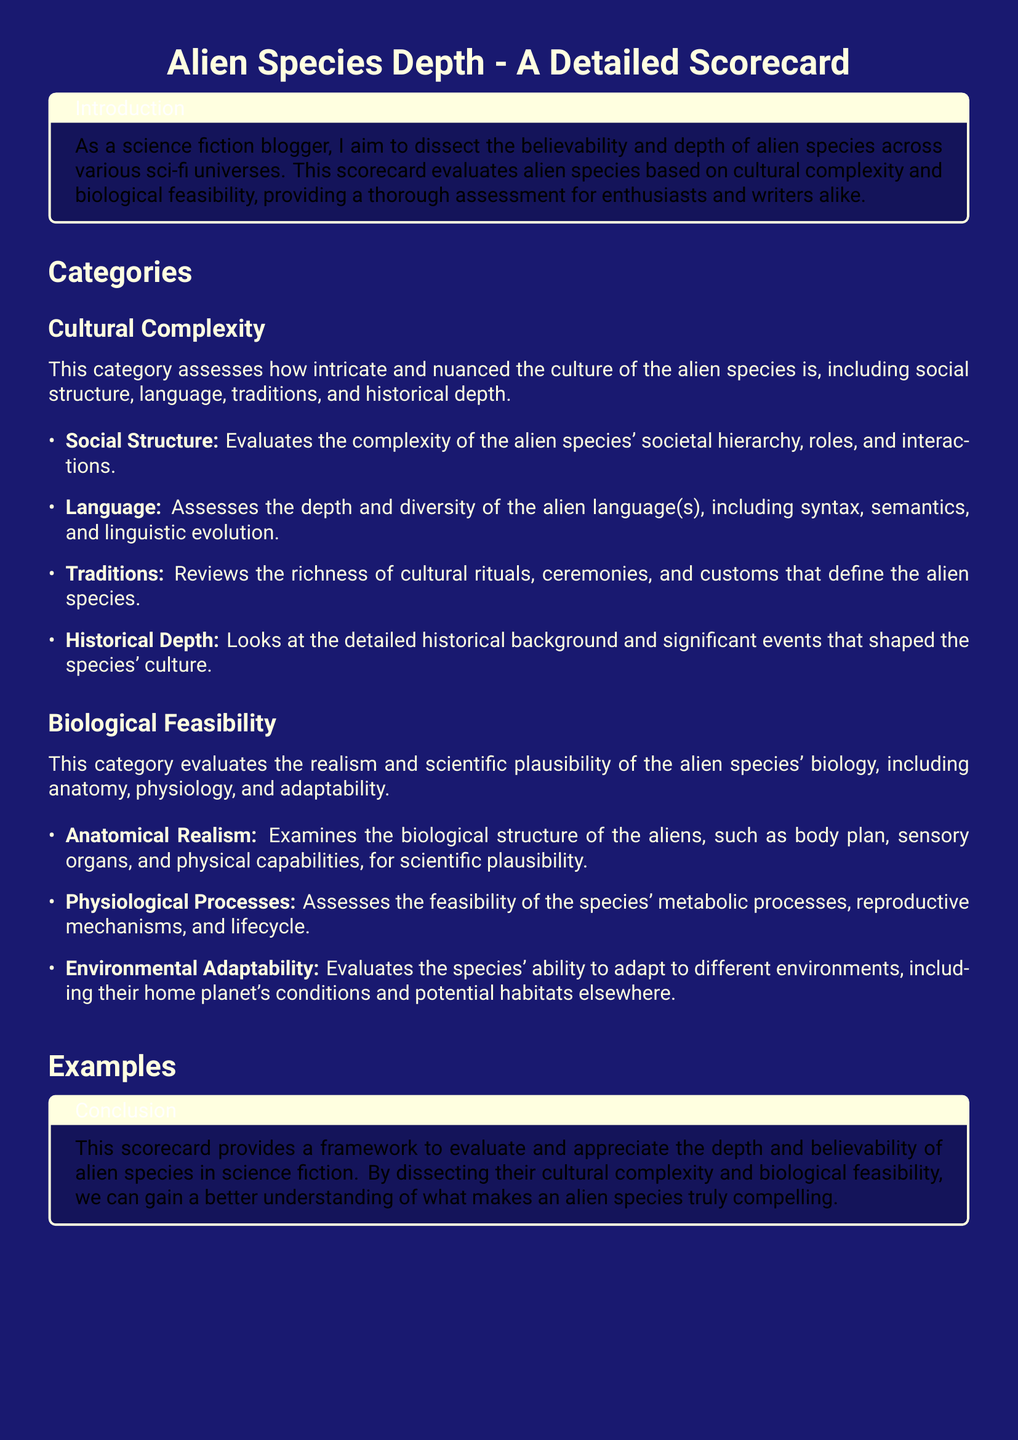What is the title of the scorecard? The title of the scorecard is prominently displayed at the beginning of the document, which is "Alien Species Depth - A Detailed Scorecard."
Answer: Alien Species Depth - A Detailed Scorecard What is the cultural complexity score for Vulcans? The cultural complexity score for Vulcans is mentioned in the examples section of the scorecard.
Answer: 9 What species is described as having a cultural complexity score of 5? The species with a cultural complexity score of 5 is listed in the examples provided, which refers to the Protogen Molecule-Infected.
Answer: Protogen Molecule-Infected How many categories are used to evaluate the alien species? The scorecard outlines two main categories for evaluation, which are cultural complexity and biological feasibility.
Answer: 2 What is the lowest biological feasibility score mentioned? The biological feasibility scores for the examples are listed, and the lowest score is identified in the table for the Wookies.
Answer: 6 What aspect of alien species' culture does "Traditions" refer to? The "Traditions" aspect assesses the richness of cultural rituals, ceremonies, and customs that define the alien species.
Answer: Cultural rituals Which alien species is noted for its mind-melding ability? The species known for its mind-melding ability is explicitly mentioned in relation to its biological characteristics in the scorecard.
Answer: Vulcans What is the maximum score for cultural complexity in the document? The highest cultural complexity score in the document, as indicated in the examples, is for the Vulcans.
Answer: 9 What is the evaluative focus of the scorecard? The focus of the scorecard is to assess alien species based on complexity and feasibility aspects, specifically cultural and biological elements.
Answer: Depth and believability 